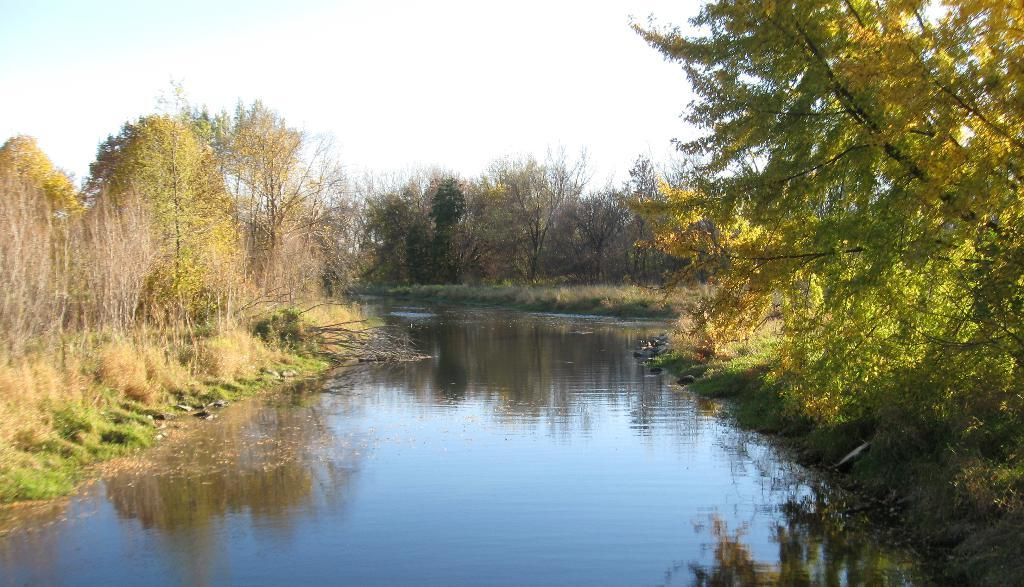What is the main feature in the center of the image? The center of the image contains the sky. What can be seen in the sky? Clouds are present in the sky. What type of vegetation is visible in the image? Trees, plants, and grass are visible in the image. What is the other natural element present in the image? Water is present in the image. What type of cake is being served to the boy in the image? There is no cake or boy present in the image; it primarily features natural elements such as the sky, clouds, trees, plants, grass, and water. 